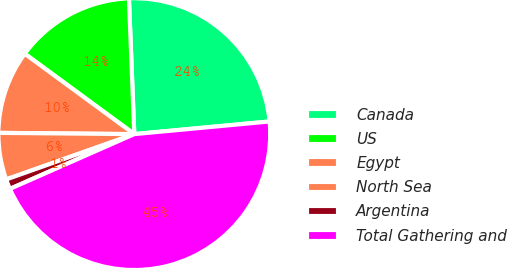Convert chart. <chart><loc_0><loc_0><loc_500><loc_500><pie_chart><fcel>Canada<fcel>US<fcel>Egypt<fcel>North Sea<fcel>Argentina<fcel>Total Gathering and<nl><fcel>24.15%<fcel>14.3%<fcel>9.93%<fcel>5.56%<fcel>1.19%<fcel>44.89%<nl></chart> 